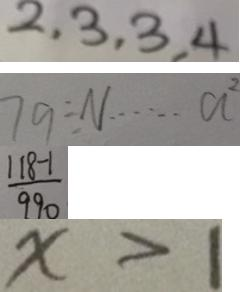Convert formula to latex. <formula><loc_0><loc_0><loc_500><loc_500>2 , 3 , 3 , 4 
 7 9 \div N \cdots a 2 
 \frac { 1 1 8 - 1 } { 9 9 0 } 
 x > 1</formula> 